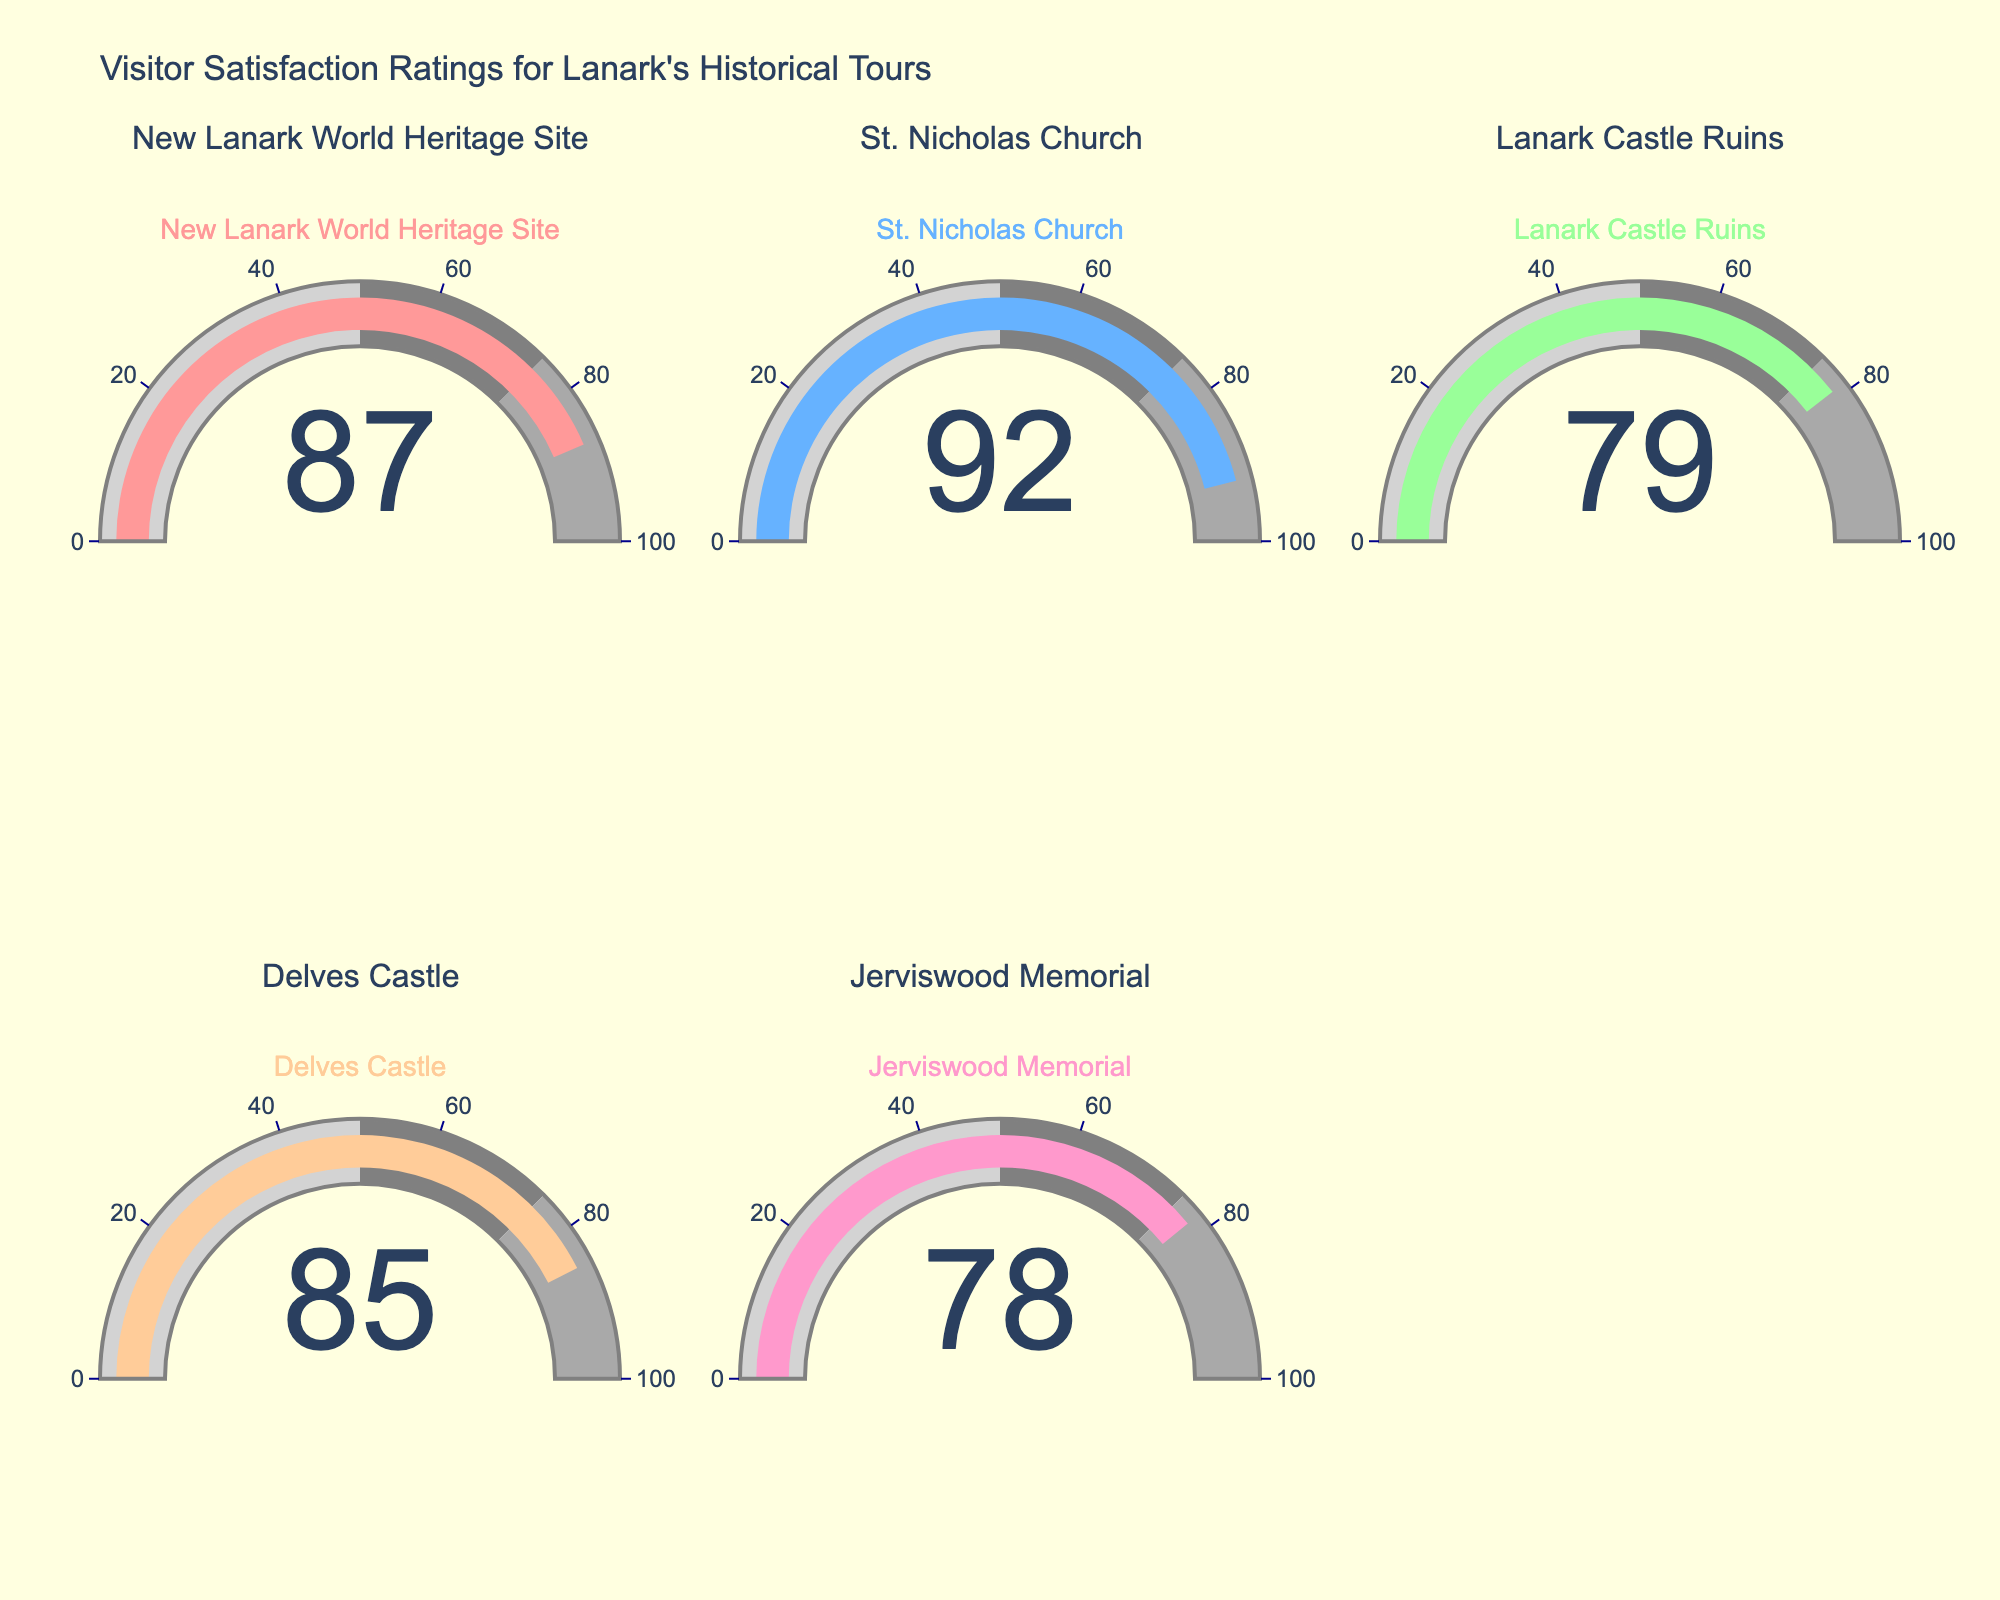What's the title of the figure? The title is displayed at the top of the figure and summarizes the subject of the data presented. It says "Visitor Satisfaction Ratings for Lanark's Historical Tours".
Answer: Visitor Satisfaction Ratings for Lanark's Historical Tours How many historical tours are shown in the figure? There are five gauge charts, each representing a different historical tour. You can count the titles of each subplot to determine the number of tours.
Answer: 5 What's the satisfaction rating for Delves Castle? Locate the gauge chart titled "Delves Castle" and refer to the number displayed in the middle of the gauge.
Answer: 85 Which historical tour has the highest satisfaction rating? Compare the numbers in the middle of each gauge. The highest number corresponds to the highest satisfaction rating, which is 92 for "St. Nicholas Church".
Answer: St. Nicholas Church Which historical tour has the lowest satisfaction rating? Compare the numbers displayed in each gauge. The lowest number is 78, corresponding to "Jerviswood Memorial".
Answer: Jerviswood Memorial What's the average satisfaction rating for all the tours combined? Add all the satisfaction ratings (87 + 92 + 79 + 85 + 78) to get a total of 421. Then, divide by the number of tours (5) to get the average: 421/5 = 84.2.
Answer: 84.2 What are the three highest satisfaction ratings displayed in the gauges? Locate and list the three highest numbers from the gauges: 92 (St. Nicholas Church), 87 (New Lanark World Heritage Site), and 85 (Delves Castle).
Answer: 92, 87, 85 How much higher is the satisfaction rating for St. Nicholas Church compared to Lanark Castle Ruins? Subtract the satisfaction rating of Lanark Castle Ruins (79) from that of St. Nicholas Church (92): 92 - 79 = 13.
Answer: 13 If the average satisfaction rating is the benchmark, how many tours exceed this average? First, we calculated the average satisfaction rating as 84.2. Then, count the tours with ratings above 84.2. There are 3 tours (New Lanark World Heritage Site - 87, St. Nicholas Church - 92, Delves Castle - 85).
Answer: 3 Assuming a threshold for excellence is set at 90, which tours meet this threshold? Compare each satisfaction rating to the threshold of 90. Only the "St. Nicholas Church" with a rating of 92 meets this threshold.
Answer: St. Nicholas Church 